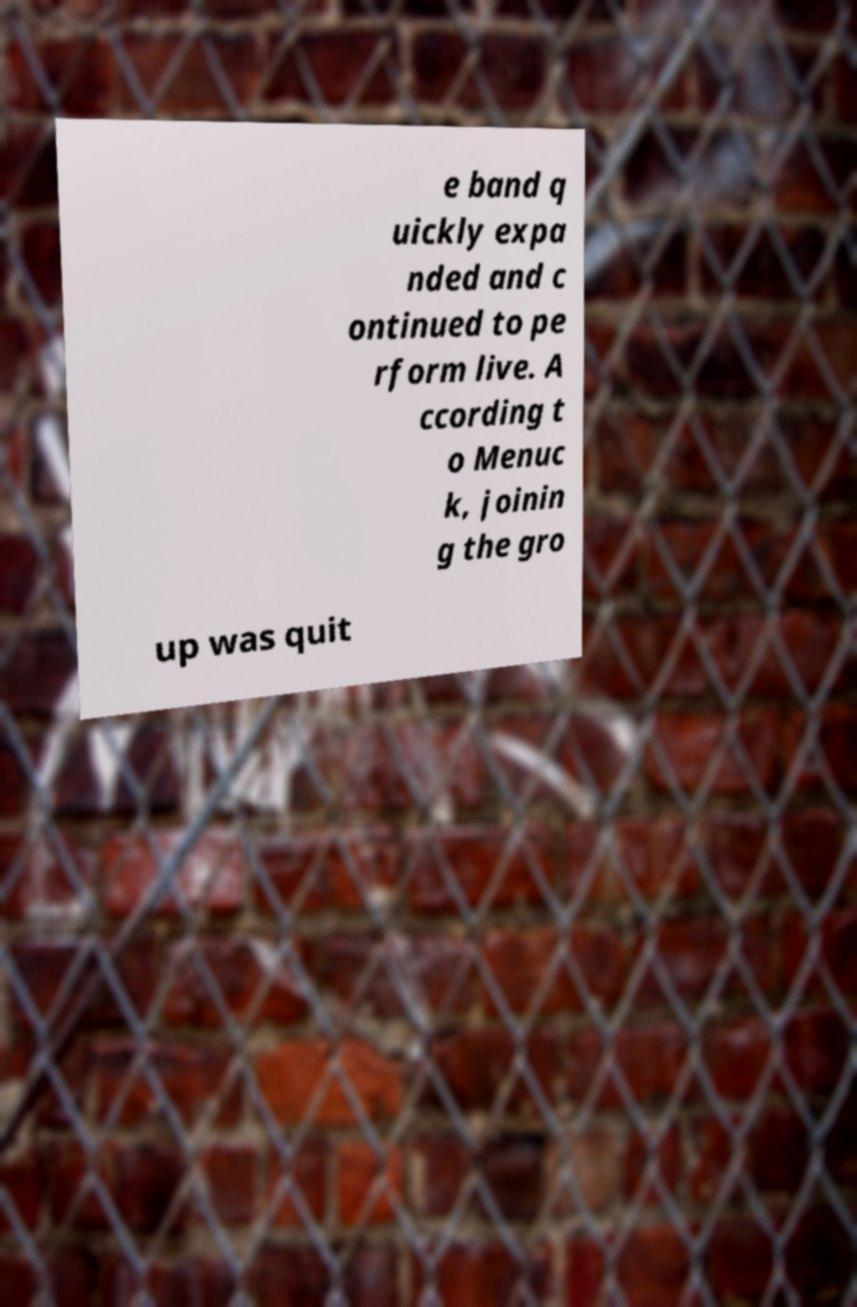Can you read and provide the text displayed in the image?This photo seems to have some interesting text. Can you extract and type it out for me? e band q uickly expa nded and c ontinued to pe rform live. A ccording t o Menuc k, joinin g the gro up was quit 